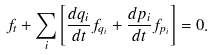<formula> <loc_0><loc_0><loc_500><loc_500>f _ { t } + \sum _ { i } \left [ \frac { d q _ { i } } { d t } f _ { q _ { i } } + \frac { d p _ { i } } { d t } f _ { p _ { i } } \right ] = 0 .</formula> 